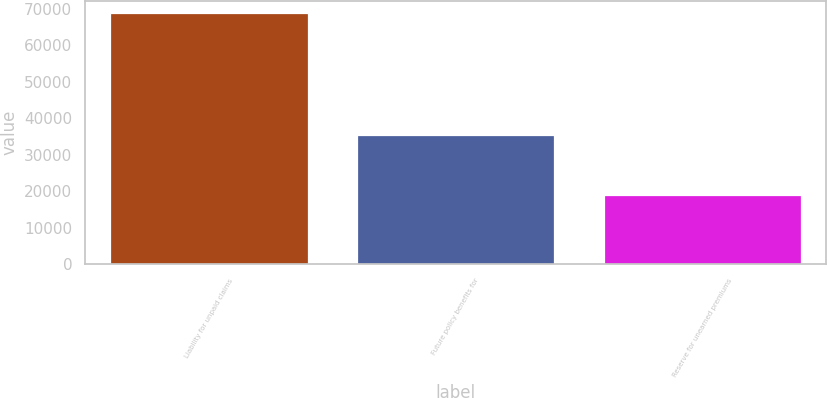Convert chart to OTSL. <chart><loc_0><loc_0><loc_500><loc_500><bar_chart><fcel>Liability for unpaid claims<fcel>Future policy benefits for<fcel>Reserve for unearned premiums<nl><fcel>68782<fcel>35408<fcel>18934<nl></chart> 